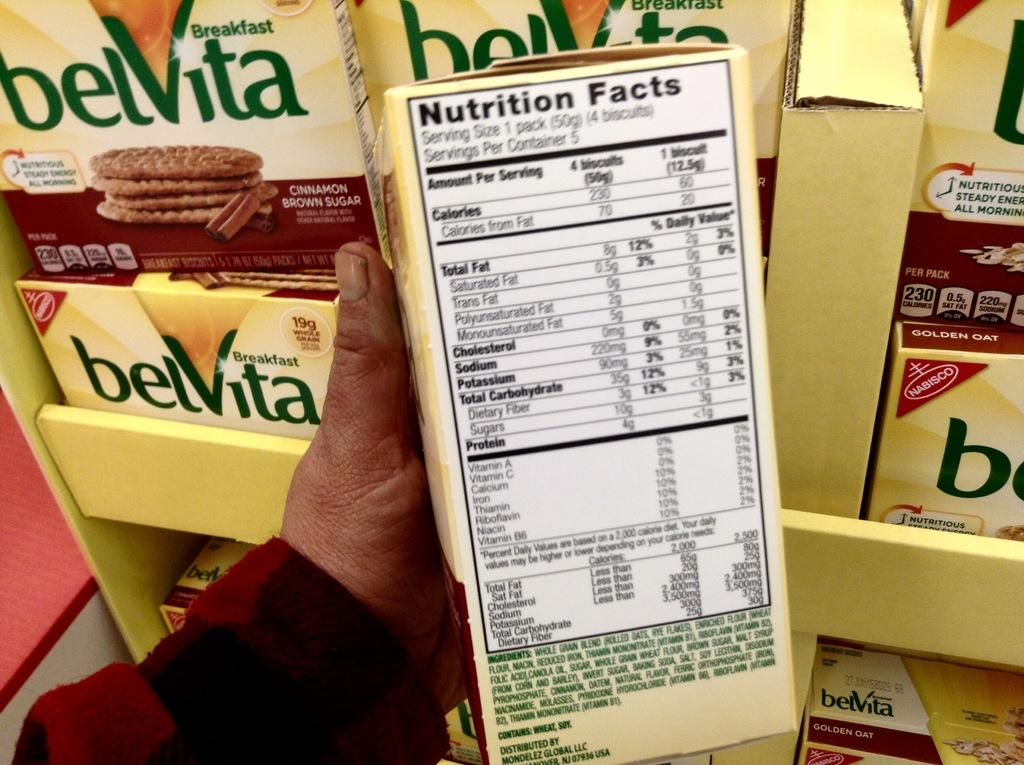<image>
Write a terse but informative summary of the picture. A box of belvita nutrition facts is being shown by a person's hand. 